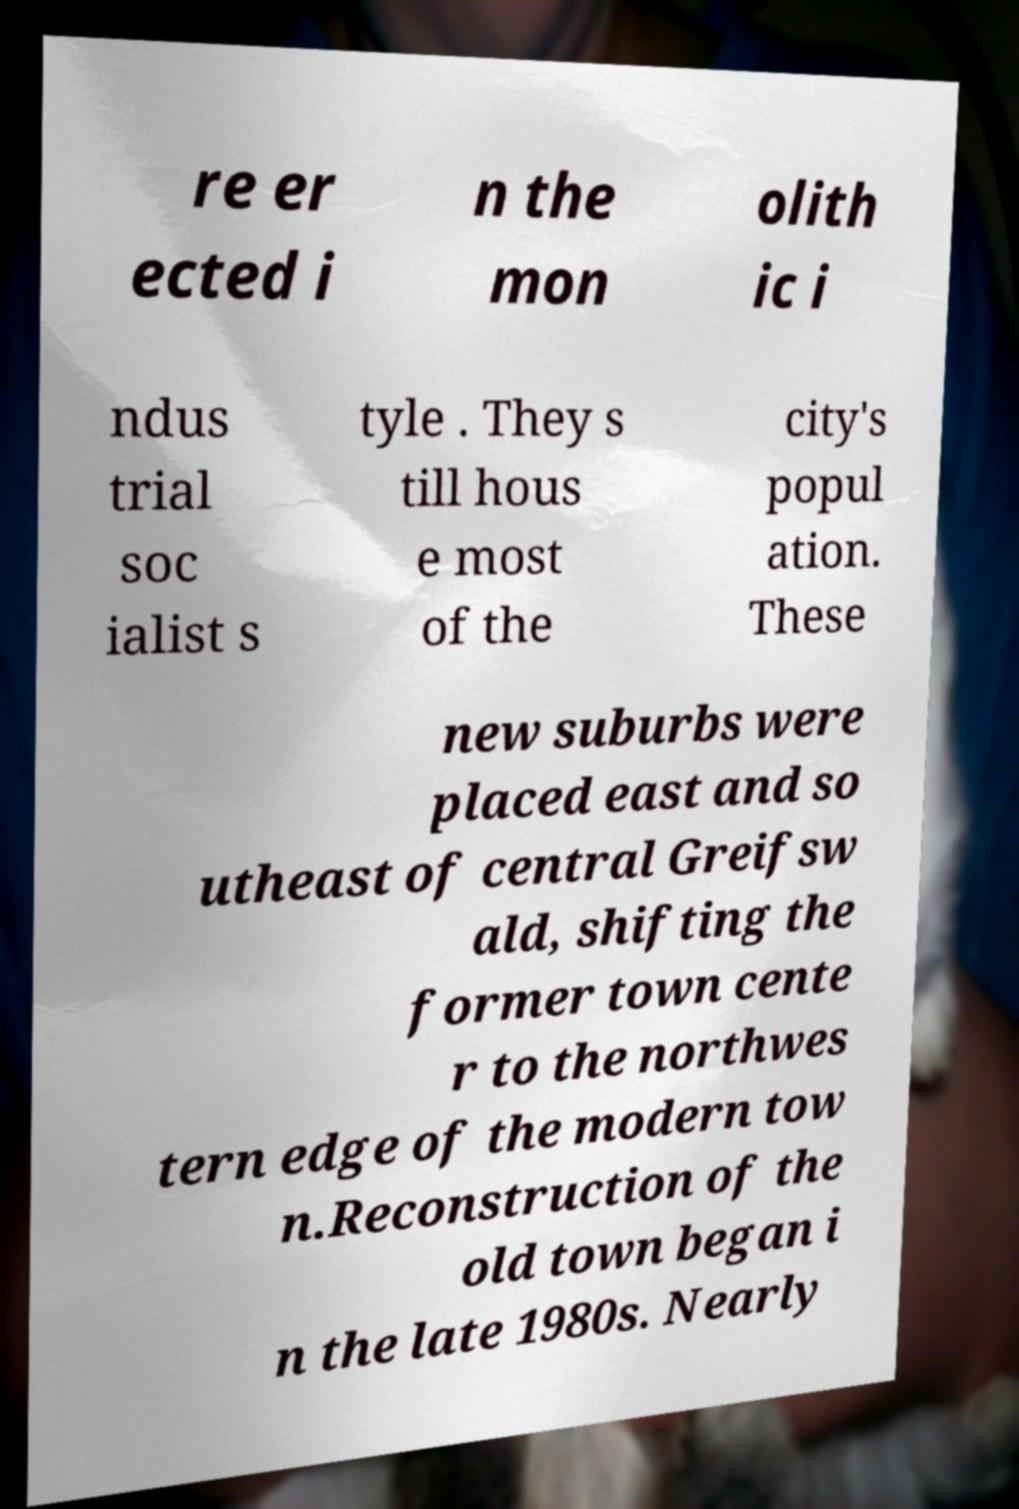There's text embedded in this image that I need extracted. Can you transcribe it verbatim? re er ected i n the mon olith ic i ndus trial soc ialist s tyle . They s till hous e most of the city's popul ation. These new suburbs were placed east and so utheast of central Greifsw ald, shifting the former town cente r to the northwes tern edge of the modern tow n.Reconstruction of the old town began i n the late 1980s. Nearly 